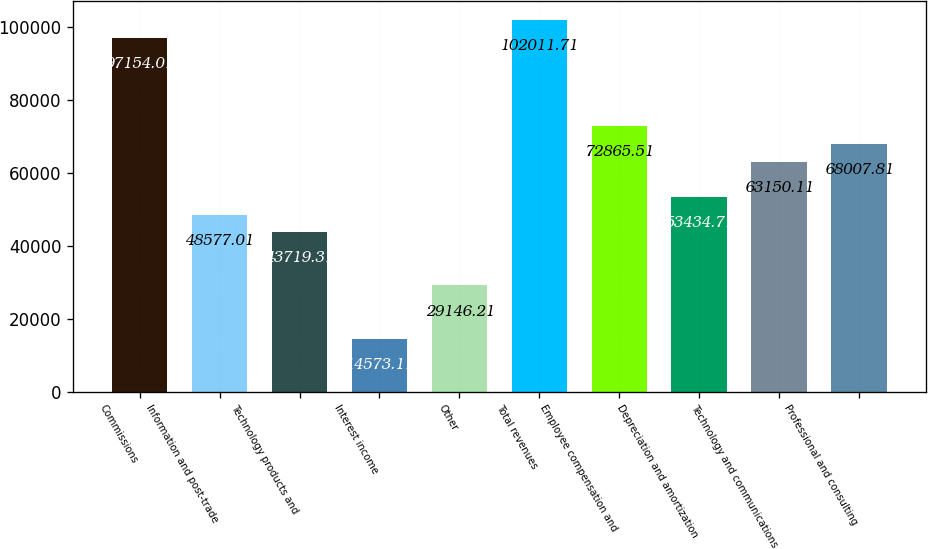Convert chart to OTSL. <chart><loc_0><loc_0><loc_500><loc_500><bar_chart><fcel>Commissions<fcel>Information and post-trade<fcel>Technology products and<fcel>Interest income<fcel>Other<fcel>Total revenues<fcel>Employee compensation and<fcel>Depreciation and amortization<fcel>Technology and communications<fcel>Professional and consulting<nl><fcel>97154<fcel>48577<fcel>43719.3<fcel>14573.1<fcel>29146.2<fcel>102012<fcel>72865.5<fcel>53434.7<fcel>63150.1<fcel>68007.8<nl></chart> 